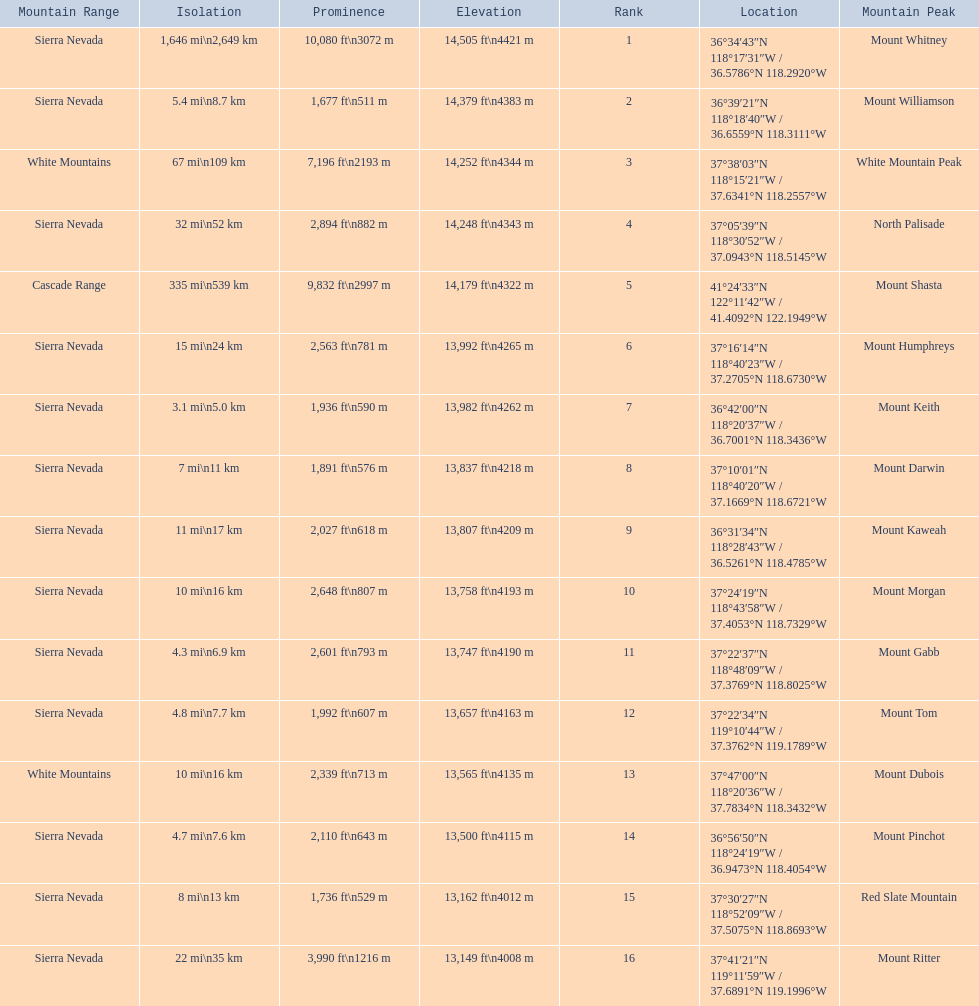What are the prominence lengths higher than 10,000 feet? 10,080 ft\n3072 m. What mountain peak has a prominence of 10,080 feet? Mount Whitney. 